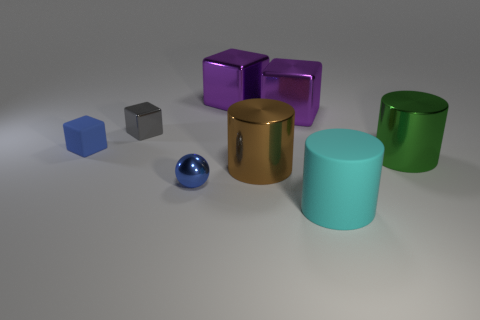Assuming these objects have different weights, which one do you think would be the heaviest and which the lightest? Judging by their size and the materials they appear to be made of, the largest brown cylinder might be the heaviest if it's solid metal, while the small blue sphere might be the lightest due to its smaller size and potentially hollow interior. 